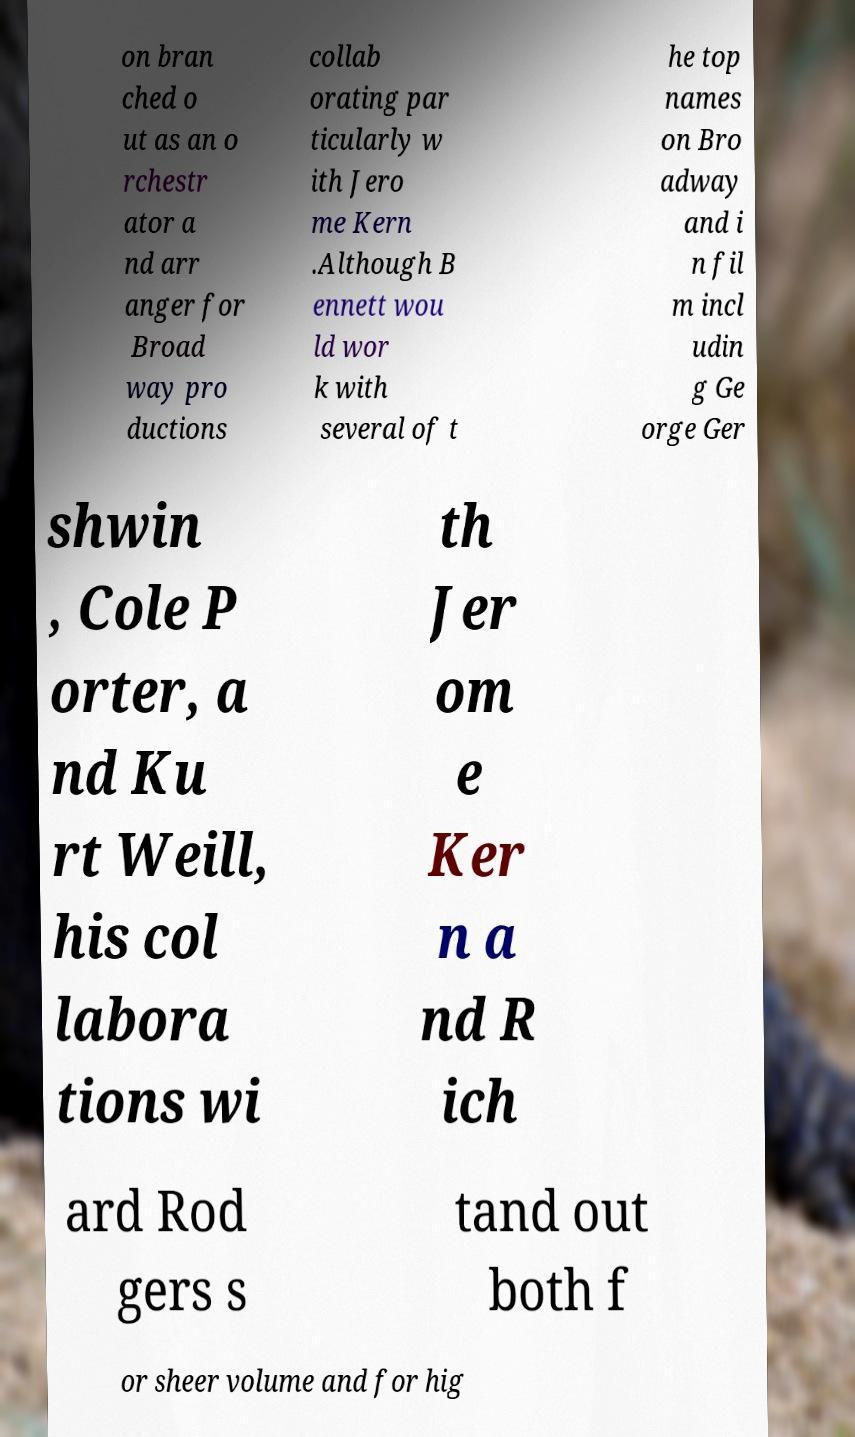Could you assist in decoding the text presented in this image and type it out clearly? on bran ched o ut as an o rchestr ator a nd arr anger for Broad way pro ductions collab orating par ticularly w ith Jero me Kern .Although B ennett wou ld wor k with several of t he top names on Bro adway and i n fil m incl udin g Ge orge Ger shwin , Cole P orter, a nd Ku rt Weill, his col labora tions wi th Jer om e Ker n a nd R ich ard Rod gers s tand out both f or sheer volume and for hig 